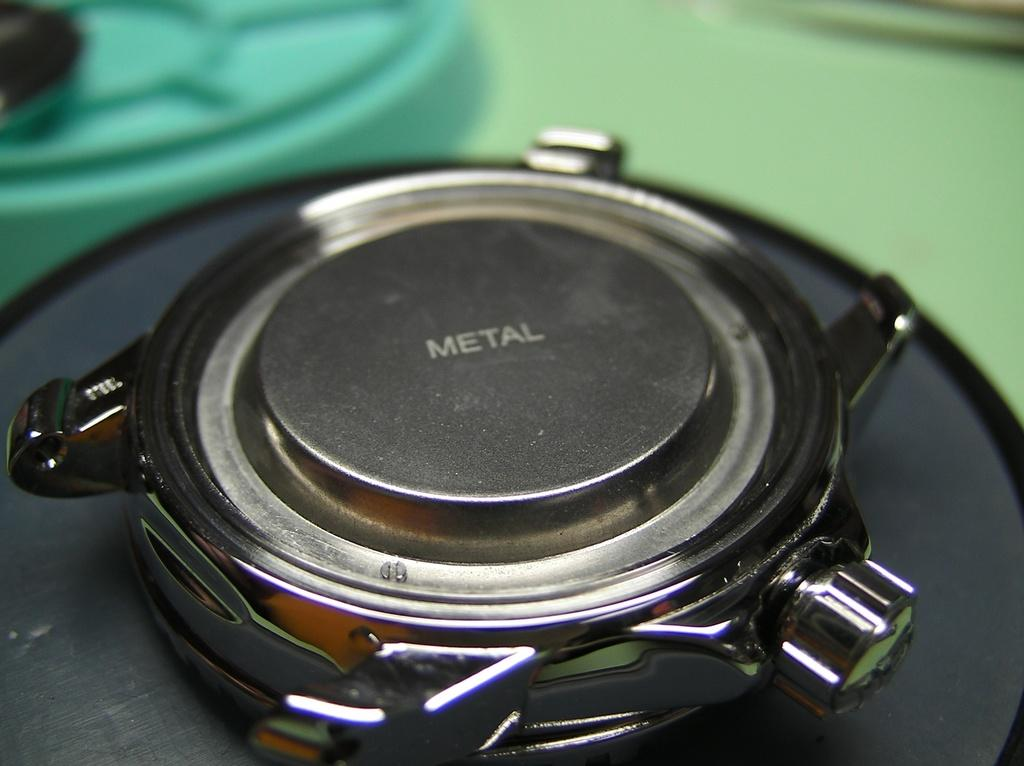<image>
Describe the image concisely. Metal is written in the center of a silver device. 